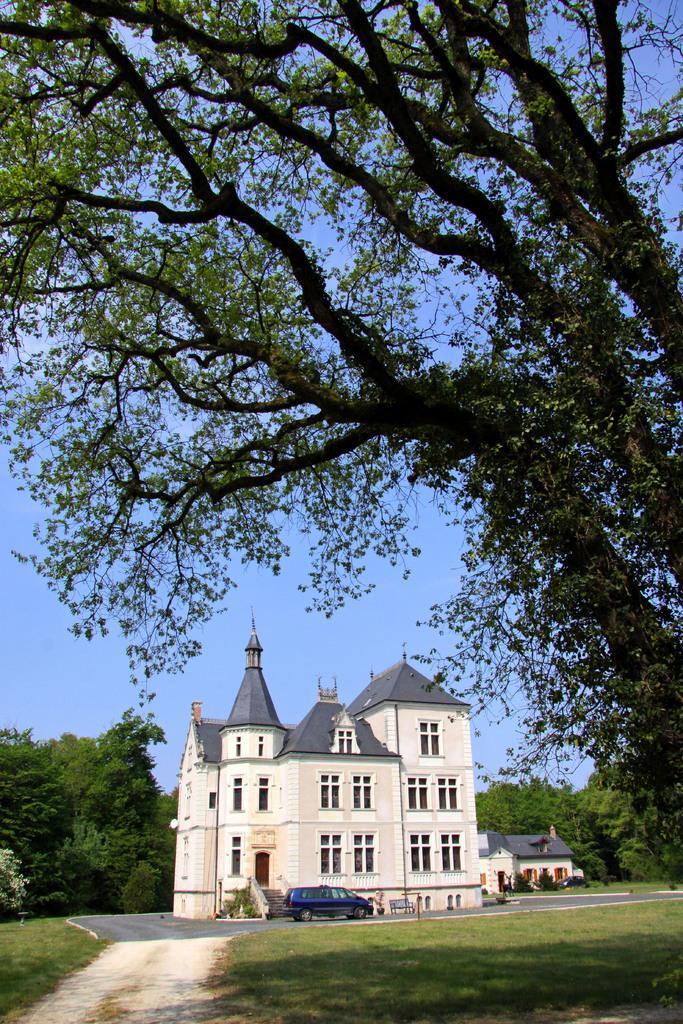Describe this image in one or two sentences. This is the picture of a place where we have a building, houses and around there are some trees, plants, grass and a car in front of the building. 